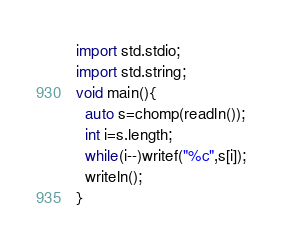Convert code to text. <code><loc_0><loc_0><loc_500><loc_500><_D_>import std.stdio;
import std.string;
void main(){
  auto s=chomp(readln());
  int i=s.length;
  while(i--)writef("%c",s[i]);
  writeln();
}</code> 